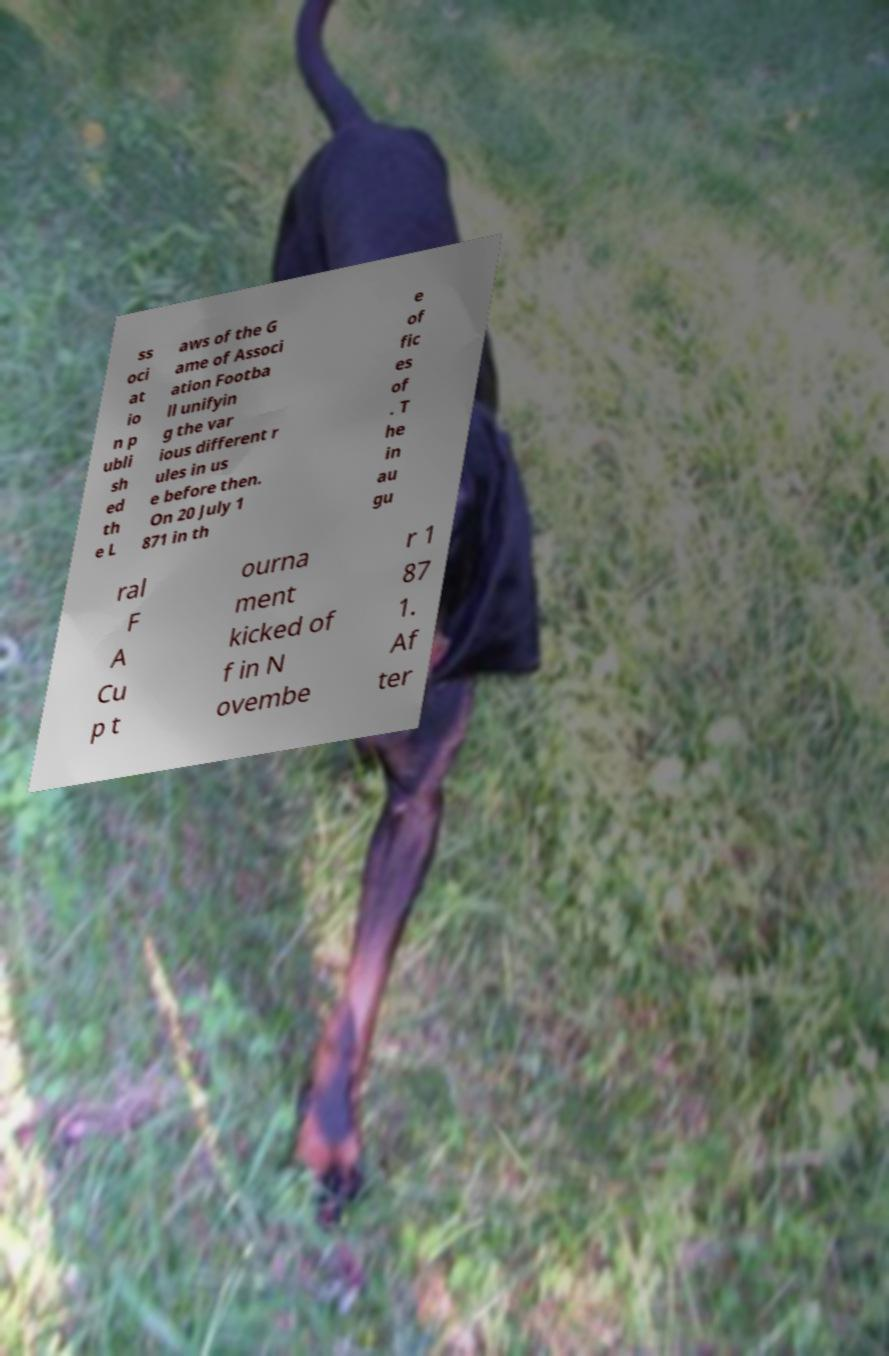Could you extract and type out the text from this image? ss oci at io n p ubli sh ed th e L aws of the G ame of Associ ation Footba ll unifyin g the var ious different r ules in us e before then. On 20 July 1 871 in th e of fic es of . T he in au gu ral F A Cu p t ourna ment kicked of f in N ovembe r 1 87 1. Af ter 